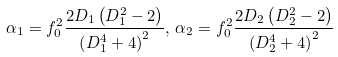<formula> <loc_0><loc_0><loc_500><loc_500>\alpha _ { 1 } = f _ { 0 } ^ { 2 } \frac { 2 D _ { 1 } \left ( D _ { 1 } ^ { 2 } - 2 \right ) } { \left ( D _ { 1 } ^ { 4 } + 4 \right ) ^ { 2 } } , \, \alpha _ { 2 } = f _ { 0 } ^ { 2 } \frac { 2 D _ { 2 } \left ( D _ { 2 } ^ { 2 } - 2 \right ) } { \left ( D _ { 2 } ^ { 4 } + 4 \right ) ^ { 2 } }</formula> 